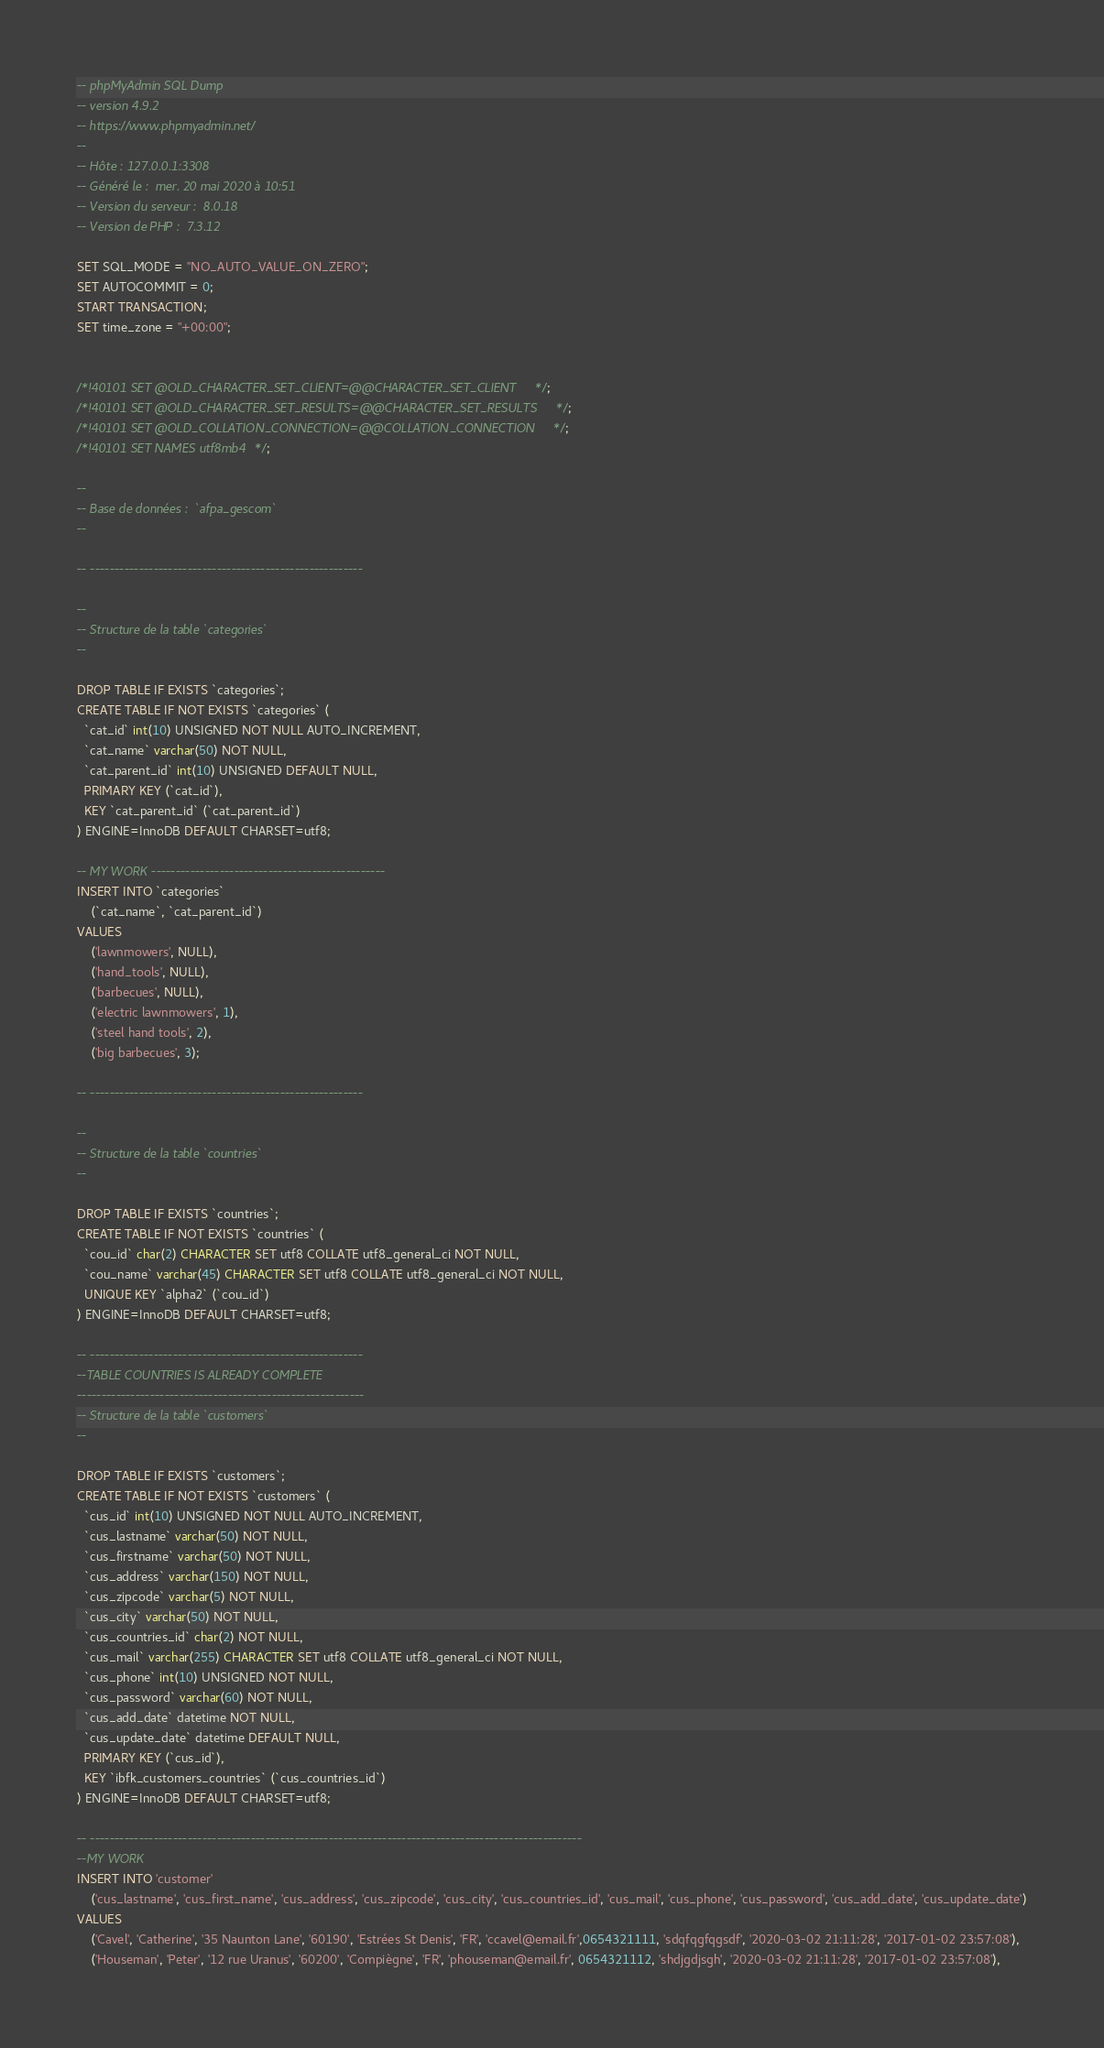<code> <loc_0><loc_0><loc_500><loc_500><_SQL_>-- phpMyAdmin SQL Dump
-- version 4.9.2
-- https://www.phpmyadmin.net/
--
-- Hôte : 127.0.0.1:3308
-- Généré le :  mer. 20 mai 2020 à 10:51
-- Version du serveur :  8.0.18
-- Version de PHP :  7.3.12

SET SQL_MODE = "NO_AUTO_VALUE_ON_ZERO";
SET AUTOCOMMIT = 0;
START TRANSACTION;
SET time_zone = "+00:00";


/*!40101 SET @OLD_CHARACTER_SET_CLIENT=@@CHARACTER_SET_CLIENT */;
/*!40101 SET @OLD_CHARACTER_SET_RESULTS=@@CHARACTER_SET_RESULTS */;
/*!40101 SET @OLD_COLLATION_CONNECTION=@@COLLATION_CONNECTION */;
/*!40101 SET NAMES utf8mb4 */;

--
-- Base de données :  `afpa_gescom`
--

-- --------------------------------------------------------

--
-- Structure de la table `categories`
--

DROP TABLE IF EXISTS `categories`;
CREATE TABLE IF NOT EXISTS `categories` (
  `cat_id` int(10) UNSIGNED NOT NULL AUTO_INCREMENT,
  `cat_name` varchar(50) NOT NULL,
  `cat_parent_id` int(10) UNSIGNED DEFAULT NULL,
  PRIMARY KEY (`cat_id`),
  KEY `cat_parent_id` (`cat_parent_id`)
) ENGINE=InnoDB DEFAULT CHARSET=utf8;

-- MY WORK ------------------------------------------------
INSERT INTO `categories` 
    (`cat_name`, `cat_parent_id`)
VALUES
    ('lawnmowers', NULL),
    ('hand_tools', NULL),
    ('barbecues', NULL),
    ('electric lawnmowers', 1),
    ('steel hand tools', 2),
    ('big barbecues', 3);

-- --------------------------------------------------------

--
-- Structure de la table `countries`
--

DROP TABLE IF EXISTS `countries`;
CREATE TABLE IF NOT EXISTS `countries` (
  `cou_id` char(2) CHARACTER SET utf8 COLLATE utf8_general_ci NOT NULL,
  `cou_name` varchar(45) CHARACTER SET utf8 COLLATE utf8_general_ci NOT NULL,
  UNIQUE KEY `alpha2` (`cou_id`)
) ENGINE=InnoDB DEFAULT CHARSET=utf8;

-- --------------------------------------------------------
--TABLE COUNTRIES IS ALREADY COMPLETE
-----------------------------------------------------------
-- Structure de la table `customers`
--

DROP TABLE IF EXISTS `customers`;
CREATE TABLE IF NOT EXISTS `customers` (
  `cus_id` int(10) UNSIGNED NOT NULL AUTO_INCREMENT,
  `cus_lastname` varchar(50) NOT NULL,
  `cus_firstname` varchar(50) NOT NULL,
  `cus_address` varchar(150) NOT NULL,
  `cus_zipcode` varchar(5) NOT NULL,
  `cus_city` varchar(50) NOT NULL,
  `cus_countries_id` char(2) NOT NULL,
  `cus_mail` varchar(255) CHARACTER SET utf8 COLLATE utf8_general_ci NOT NULL,
  `cus_phone` int(10) UNSIGNED NOT NULL,
  `cus_password` varchar(60) NOT NULL,
  `cus_add_date` datetime NOT NULL,
  `cus_update_date` datetime DEFAULT NULL,
  PRIMARY KEY (`cus_id`),
  KEY `ibfk_customers_countries` (`cus_countries_id`)
) ENGINE=InnoDB DEFAULT CHARSET=utf8;

-- -----------------------------------------------------------------------------------------------------
--MY WORK
INSERT INTO 'customer'
    ('cus_lastname', 'cus_first_name', 'cus_address', 'cus_zipcode', 'cus_city', 'cus_countries_id', 'cus_mail', 'cus_phone', 'cus_password', 'cus_add_date', 'cus_update_date')
VALUES
    ('Cavel', 'Catherine', '35 Naunton Lane', '60190', 'Estrées St Denis', 'FR', 'ccavel@email.fr',0654321111, 'sdqfqgfqgsdf', '2020-03-02 21:11:28', '2017-01-02 23:57:08'),
    ('Houseman', 'Peter', '12 rue Uranus', '60200', 'Compiègne', 'FR', 'phouseman@email.fr', 0654321112, 'shdjgdjsgh', '2020-03-02 21:11:28', '2017-01-02 23:57:08'),</code> 